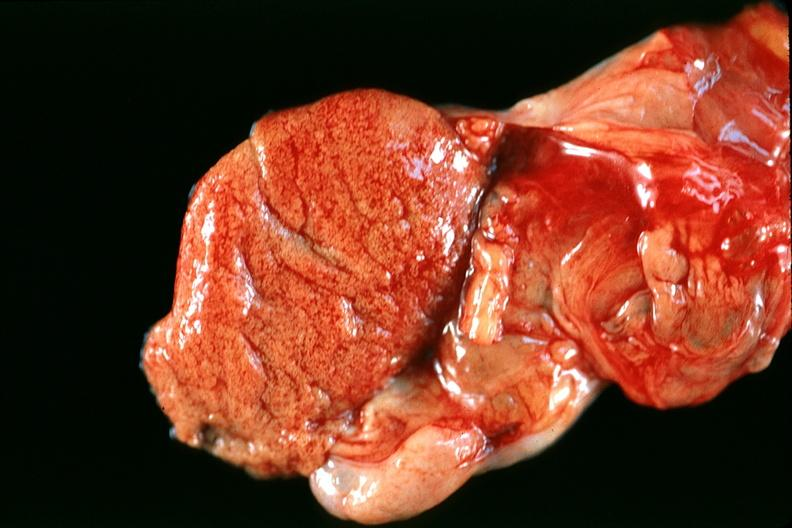s male reproductive present?
Answer the question using a single word or phrase. Yes 